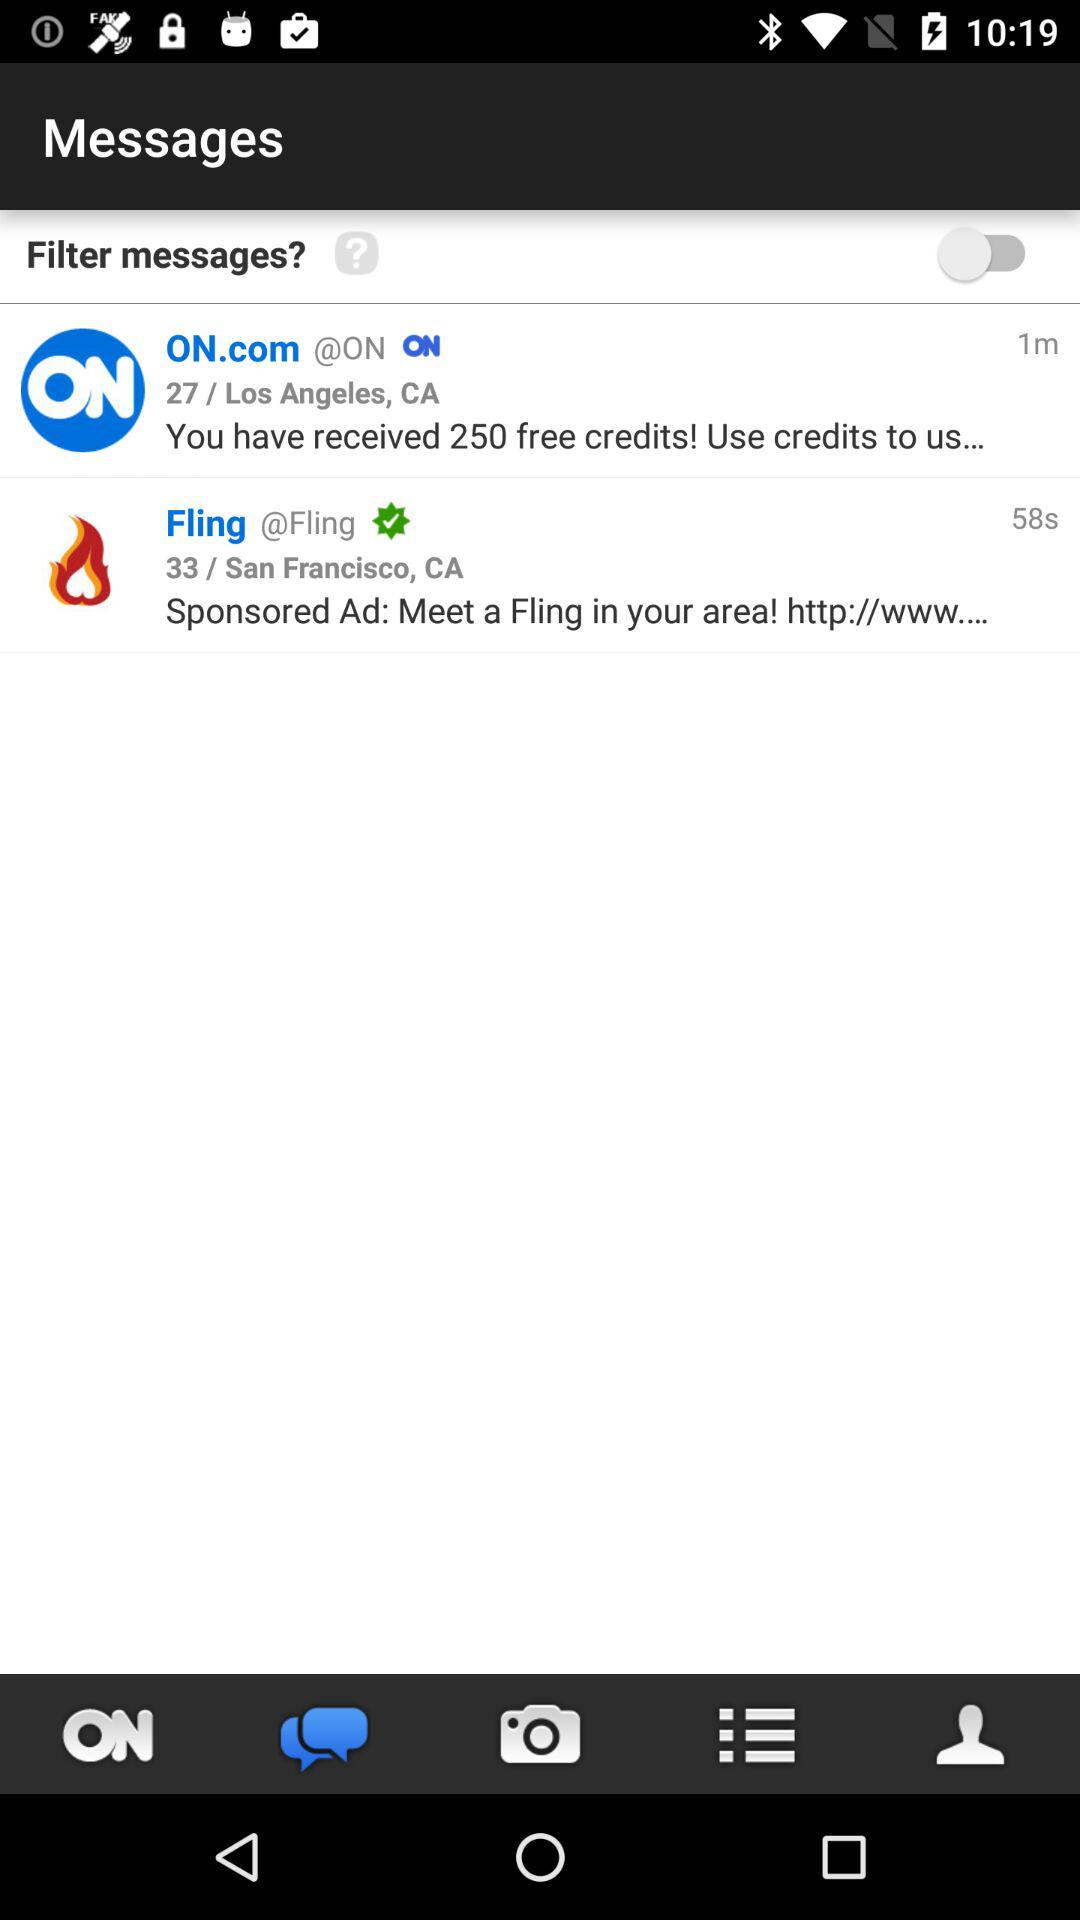What is the status of filter messages? The status is "off". 